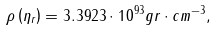<formula> <loc_0><loc_0><loc_500><loc_500>\rho \left ( \eta _ { r } \right ) = 3 . 3 9 2 3 \cdot 1 0 ^ { 9 3 } g r \cdot c m ^ { - 3 } ,</formula> 